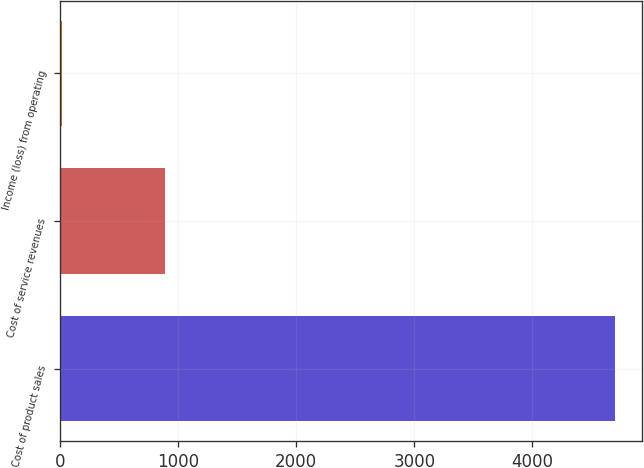Convert chart. <chart><loc_0><loc_0><loc_500><loc_500><bar_chart><fcel>Cost of product sales<fcel>Cost of service revenues<fcel>Income (loss) from operating<nl><fcel>4695<fcel>888<fcel>14<nl></chart> 